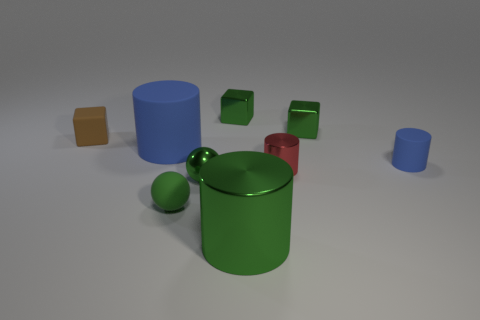What number of other things are made of the same material as the brown thing?
Your response must be concise. 3. How many matte objects are either balls or tiny green blocks?
Make the answer very short. 1. Are there fewer small blocks than green metallic spheres?
Ensure brevity in your answer.  No. Do the red thing and the blue cylinder right of the large blue cylinder have the same size?
Give a very brief answer. Yes. What is the size of the green shiny cylinder?
Provide a short and direct response. Large. Is the number of blue rubber things that are in front of the big shiny thing less than the number of big blue matte cylinders?
Ensure brevity in your answer.  Yes. Do the green matte ball and the brown rubber thing have the same size?
Ensure brevity in your answer.  Yes. What is the color of the cube that is the same material as the big blue cylinder?
Offer a terse response. Brown. Are there fewer tiny blue objects that are in front of the big green cylinder than tiny cubes right of the metallic sphere?
Your answer should be compact. Yes. How many small rubber cylinders are the same color as the big rubber object?
Make the answer very short. 1. 